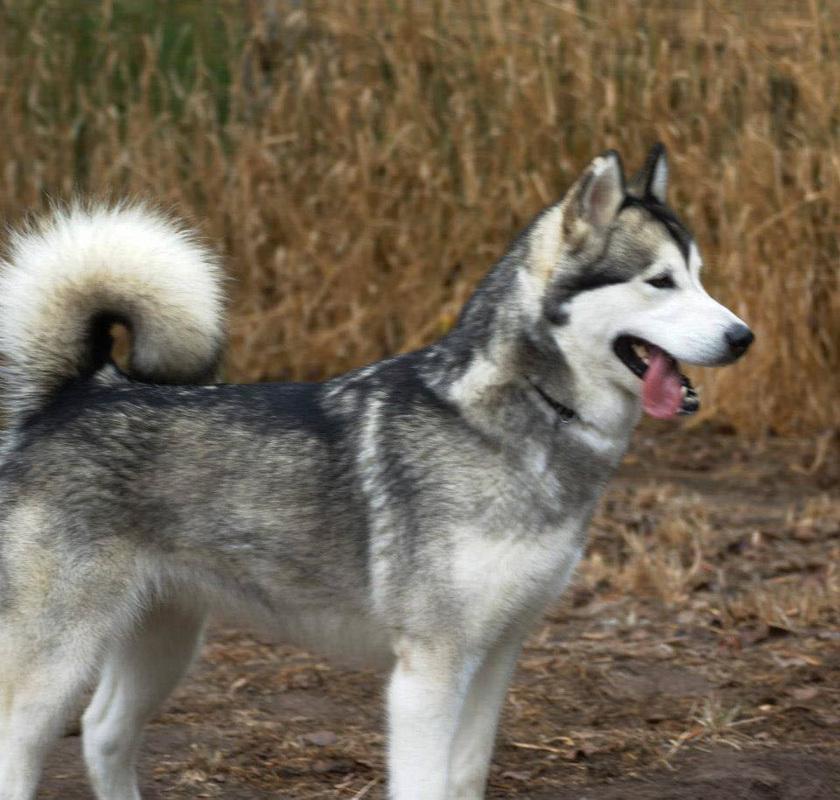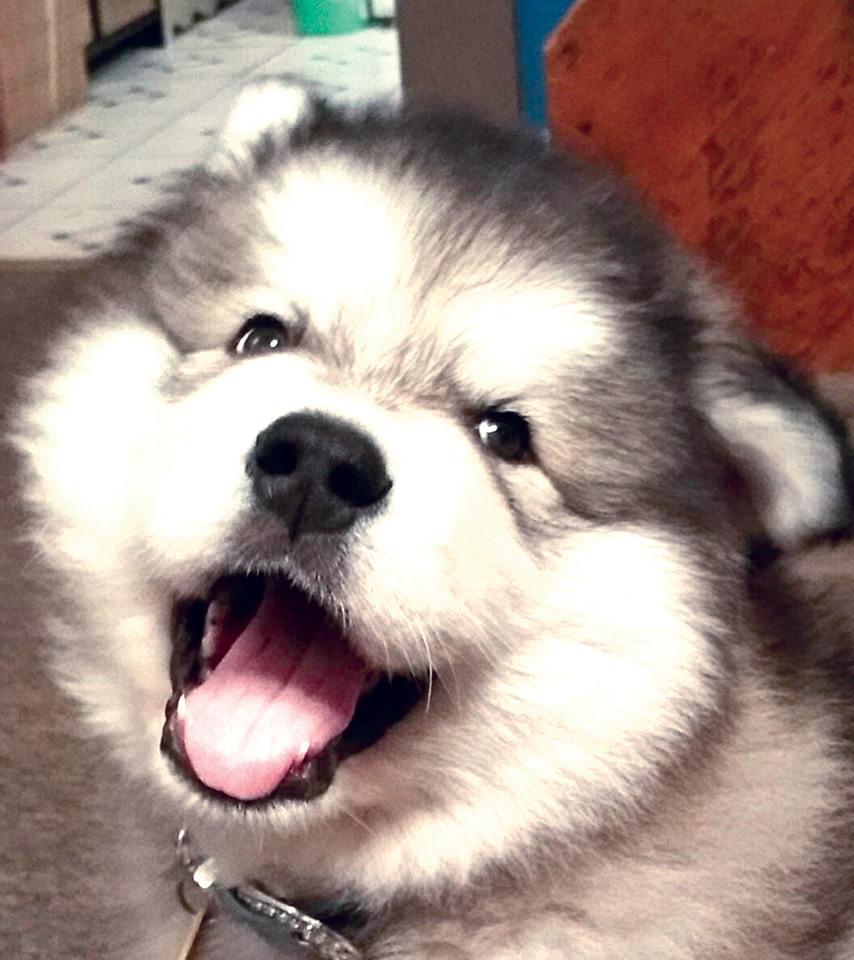The first image is the image on the left, the second image is the image on the right. Given the left and right images, does the statement "The dog in the image on the left is standing up outside." hold true? Answer yes or no. Yes. The first image is the image on the left, the second image is the image on the right. For the images shown, is this caption "A person wearing black is beside a black-and-white husky in the left image, and the right image shows a reclining dog with white and brown fur." true? Answer yes or no. No. 